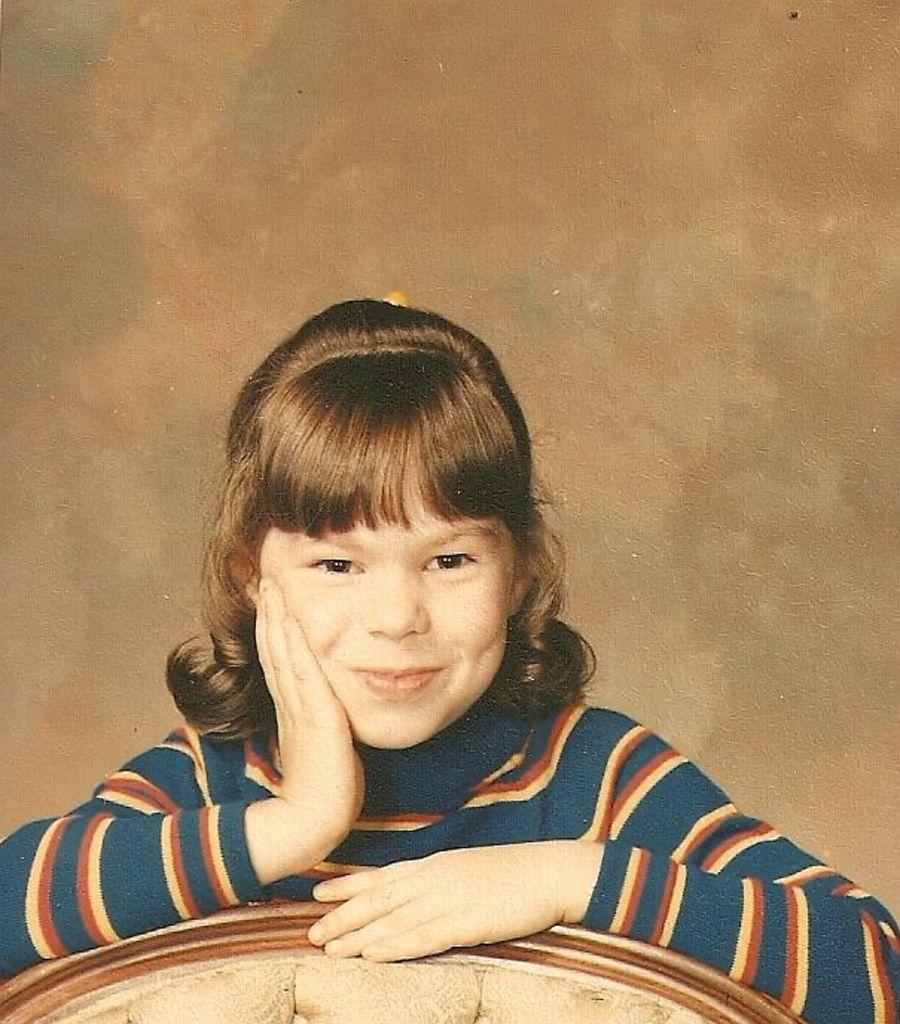Who is the main subject in the image? There is a girl in the image. What is the girl's expression in the image? The girl is smiling in the image. What object is in front of the girl? There is a chair-like object in front of the girl. What book is the girl holding in the image? There is no book present in the image. 